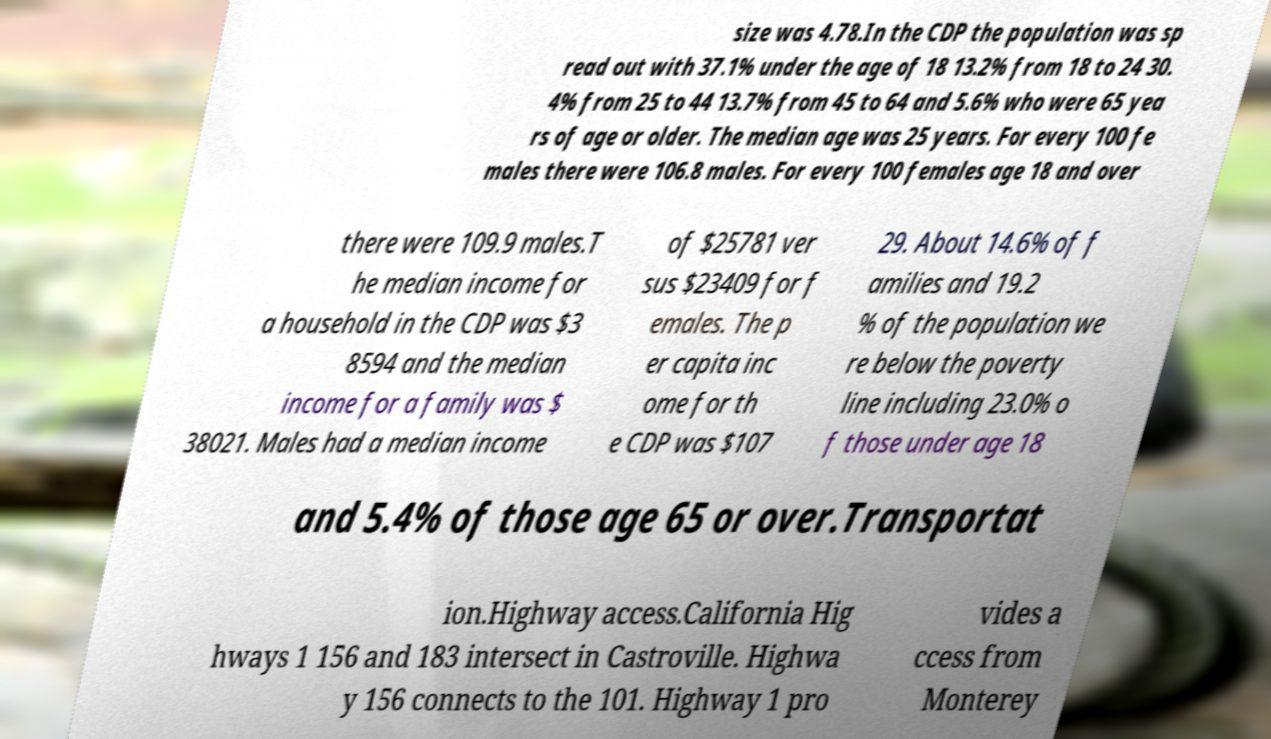I need the written content from this picture converted into text. Can you do that? size was 4.78.In the CDP the population was sp read out with 37.1% under the age of 18 13.2% from 18 to 24 30. 4% from 25 to 44 13.7% from 45 to 64 and 5.6% who were 65 yea rs of age or older. The median age was 25 years. For every 100 fe males there were 106.8 males. For every 100 females age 18 and over there were 109.9 males.T he median income for a household in the CDP was $3 8594 and the median income for a family was $ 38021. Males had a median income of $25781 ver sus $23409 for f emales. The p er capita inc ome for th e CDP was $107 29. About 14.6% of f amilies and 19.2 % of the population we re below the poverty line including 23.0% o f those under age 18 and 5.4% of those age 65 or over.Transportat ion.Highway access.California Hig hways 1 156 and 183 intersect in Castroville. Highwa y 156 connects to the 101. Highway 1 pro vides a ccess from Monterey 